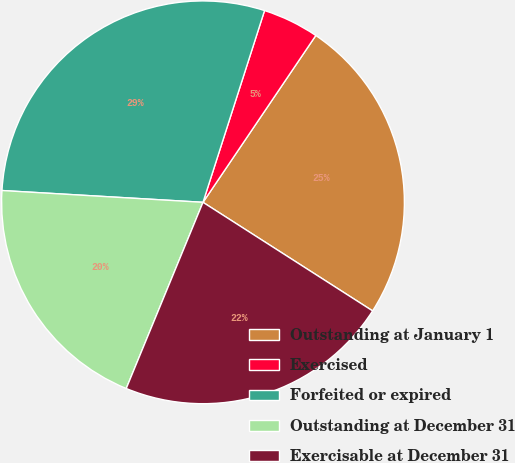<chart> <loc_0><loc_0><loc_500><loc_500><pie_chart><fcel>Outstanding at January 1<fcel>Exercised<fcel>Forfeited or expired<fcel>Outstanding at December 31<fcel>Exercisable at December 31<nl><fcel>24.6%<fcel>4.52%<fcel>29.01%<fcel>19.71%<fcel>22.16%<nl></chart> 